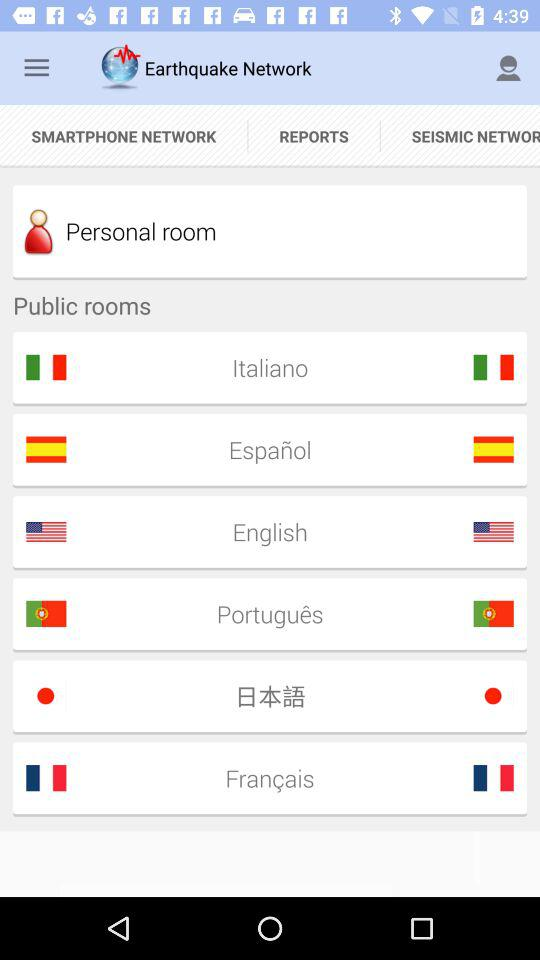How many languages are available in the public rooms?
Answer the question using a single word or phrase. 6 